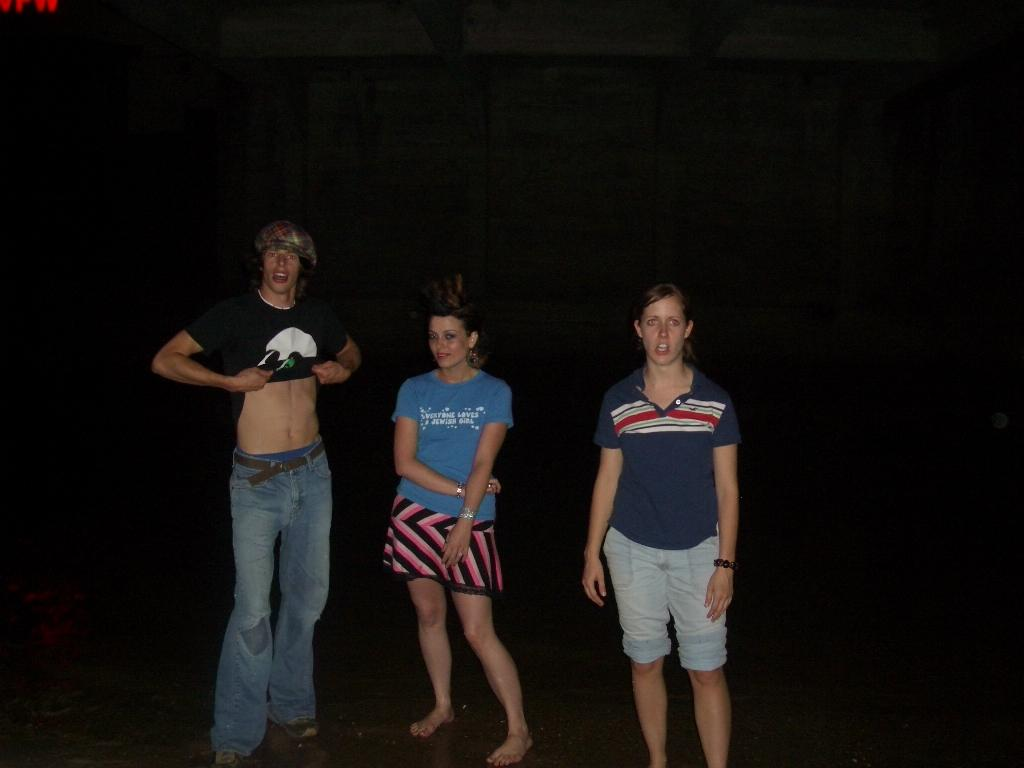<image>
Offer a succinct explanation of the picture presented. The girl in the middle wears a blue shirt that says everyone loves a Jewish girl 